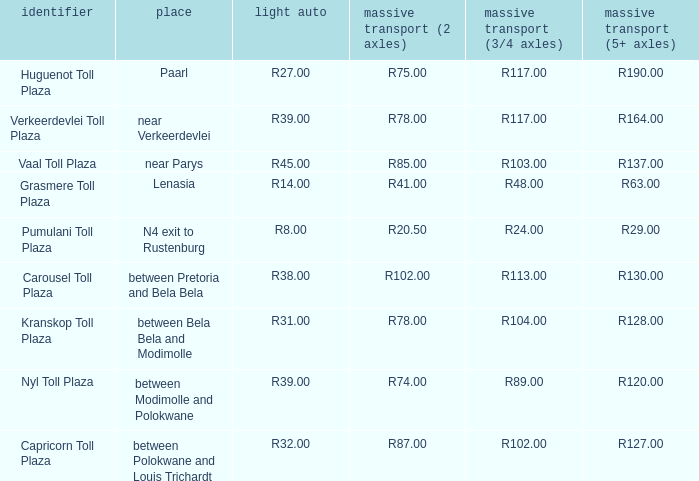What is the toll for heavy vehicles with 3/4 axles at Verkeerdevlei toll plaza? R117.00. 